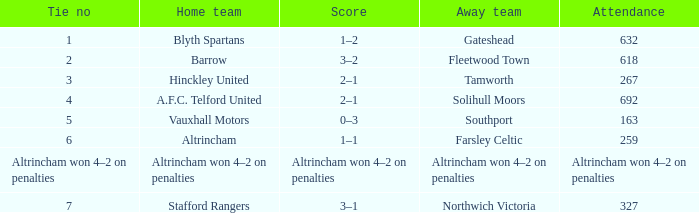What was the attendance for the away team Solihull Moors? 692.0. 